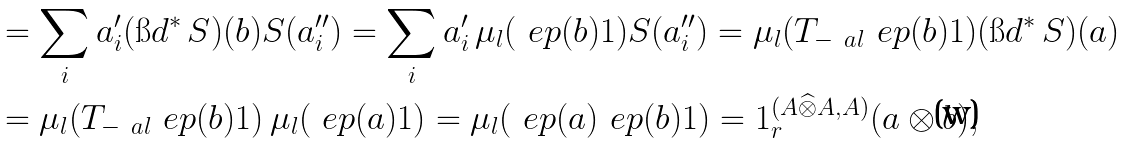Convert formula to latex. <formula><loc_0><loc_0><loc_500><loc_500>& = \sum _ { i } a _ { i } ^ { \prime } ( \i d ^ { * } \, S ) ( b ) S ( a _ { i } ^ { \prime \prime } ) = \sum _ { i } a _ { i } ^ { \prime } \, \mu _ { l } ( \ e p ( b ) 1 ) S ( a ^ { \prime \prime } _ { i } ) = \mu _ { l } ( T _ { - \ a l } \ e p ( b ) 1 ) ( \i d ^ { * } \, S ) ( a ) \\ & = \mu _ { l } ( T _ { - \ a l } \ e p ( b ) 1 ) \, \mu _ { l } ( \ e p ( a ) 1 ) = \mu _ { l } ( \ e p ( a ) \ e p ( b ) 1 ) = 1 _ { r } ^ { ( A \widehat { \otimes } A , A ) } ( a \otimes b ) ,</formula> 